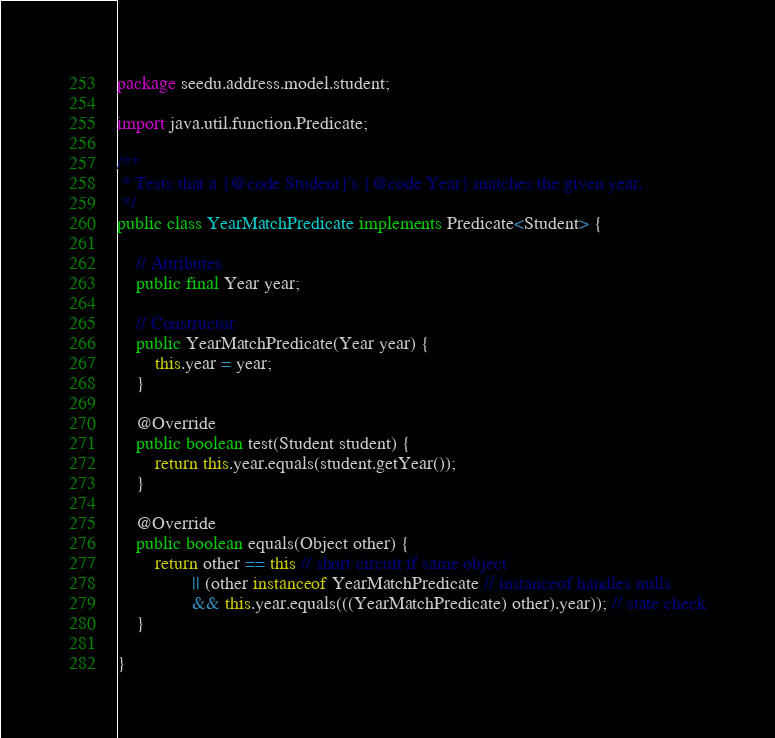Convert code to text. <code><loc_0><loc_0><loc_500><loc_500><_Java_>package seedu.address.model.student;

import java.util.function.Predicate;

/**
 * Tests that a {@code Student}'s {@code Year} matches the given year.
 */
public class YearMatchPredicate implements Predicate<Student> {

    // Attributes
    public final Year year;

    // Constructor
    public YearMatchPredicate(Year year) {
        this.year = year;
    }

    @Override
    public boolean test(Student student) {
        return this.year.equals(student.getYear());
    }

    @Override
    public boolean equals(Object other) {
        return other == this // short circuit if same object
                || (other instanceof YearMatchPredicate // instanceof handles nulls
                && this.year.equals(((YearMatchPredicate) other).year)); // state check
    }

}
</code> 